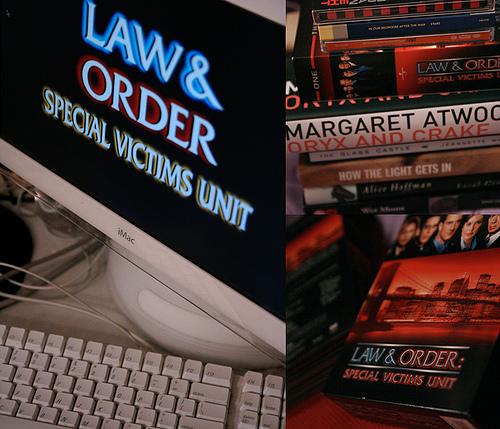What is the primary focus of the photo collage?
Keep it brief. Law and order. What game console sponsors this event?
Quick response, please. Imac. What device can you watch this show on?
Keep it brief. Computer. Is this one picture?
Concise answer only. No. 